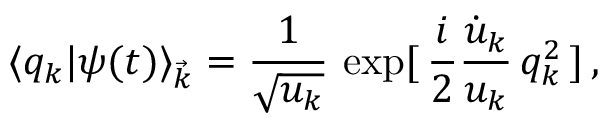Convert formula to latex. <formula><loc_0><loc_0><loc_500><loc_500>\langle q _ { k } | \psi ( t ) \rangle _ { \vec { k } } = \frac { 1 } { \sqrt { u _ { k } } } \, \exp [ \, \frac { i } { 2 } \frac { \dot { u } _ { k } } { u _ { k } } \, q _ { k } ^ { 2 } \, ] \, ,</formula> 